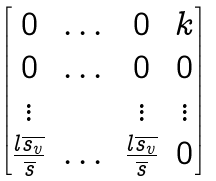Convert formula to latex. <formula><loc_0><loc_0><loc_500><loc_500>\begin{bmatrix} 0 & \dots & 0 & k \\ 0 & \dots & 0 & 0 \\ \vdots & & \vdots & \vdots \\ \frac { l \overline { s _ { v } } } { \overline { s } } & \dots & \frac { l \overline { s _ { v } } } { \overline { s } } & 0 \end{bmatrix}</formula> 